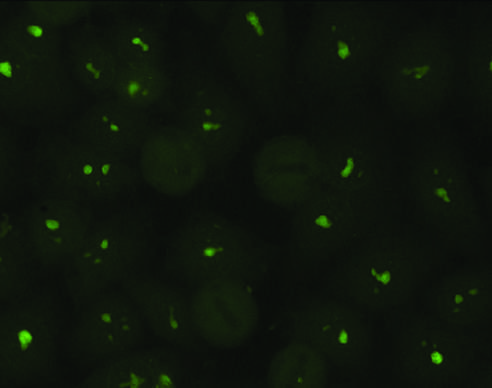what is typical of antibodies against nucleolar proteins?
Answer the question using a single word or phrase. A nucleolar pattern 